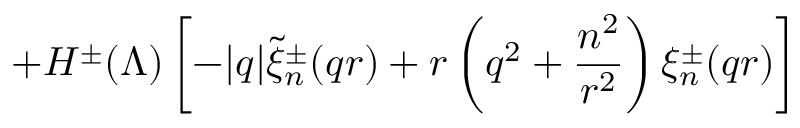<formula> <loc_0><loc_0><loc_500><loc_500>+ H ^ { \pm } ( \Lambda ) \left [ - | q | \widetilde { \xi } _ { n } ^ { \pm } ( q r ) + r \left ( q ^ { 2 } + \frac { n ^ { 2 } } { r ^ { 2 } } \right ) \xi _ { n } ^ { \pm } ( q r ) \right ]</formula> 